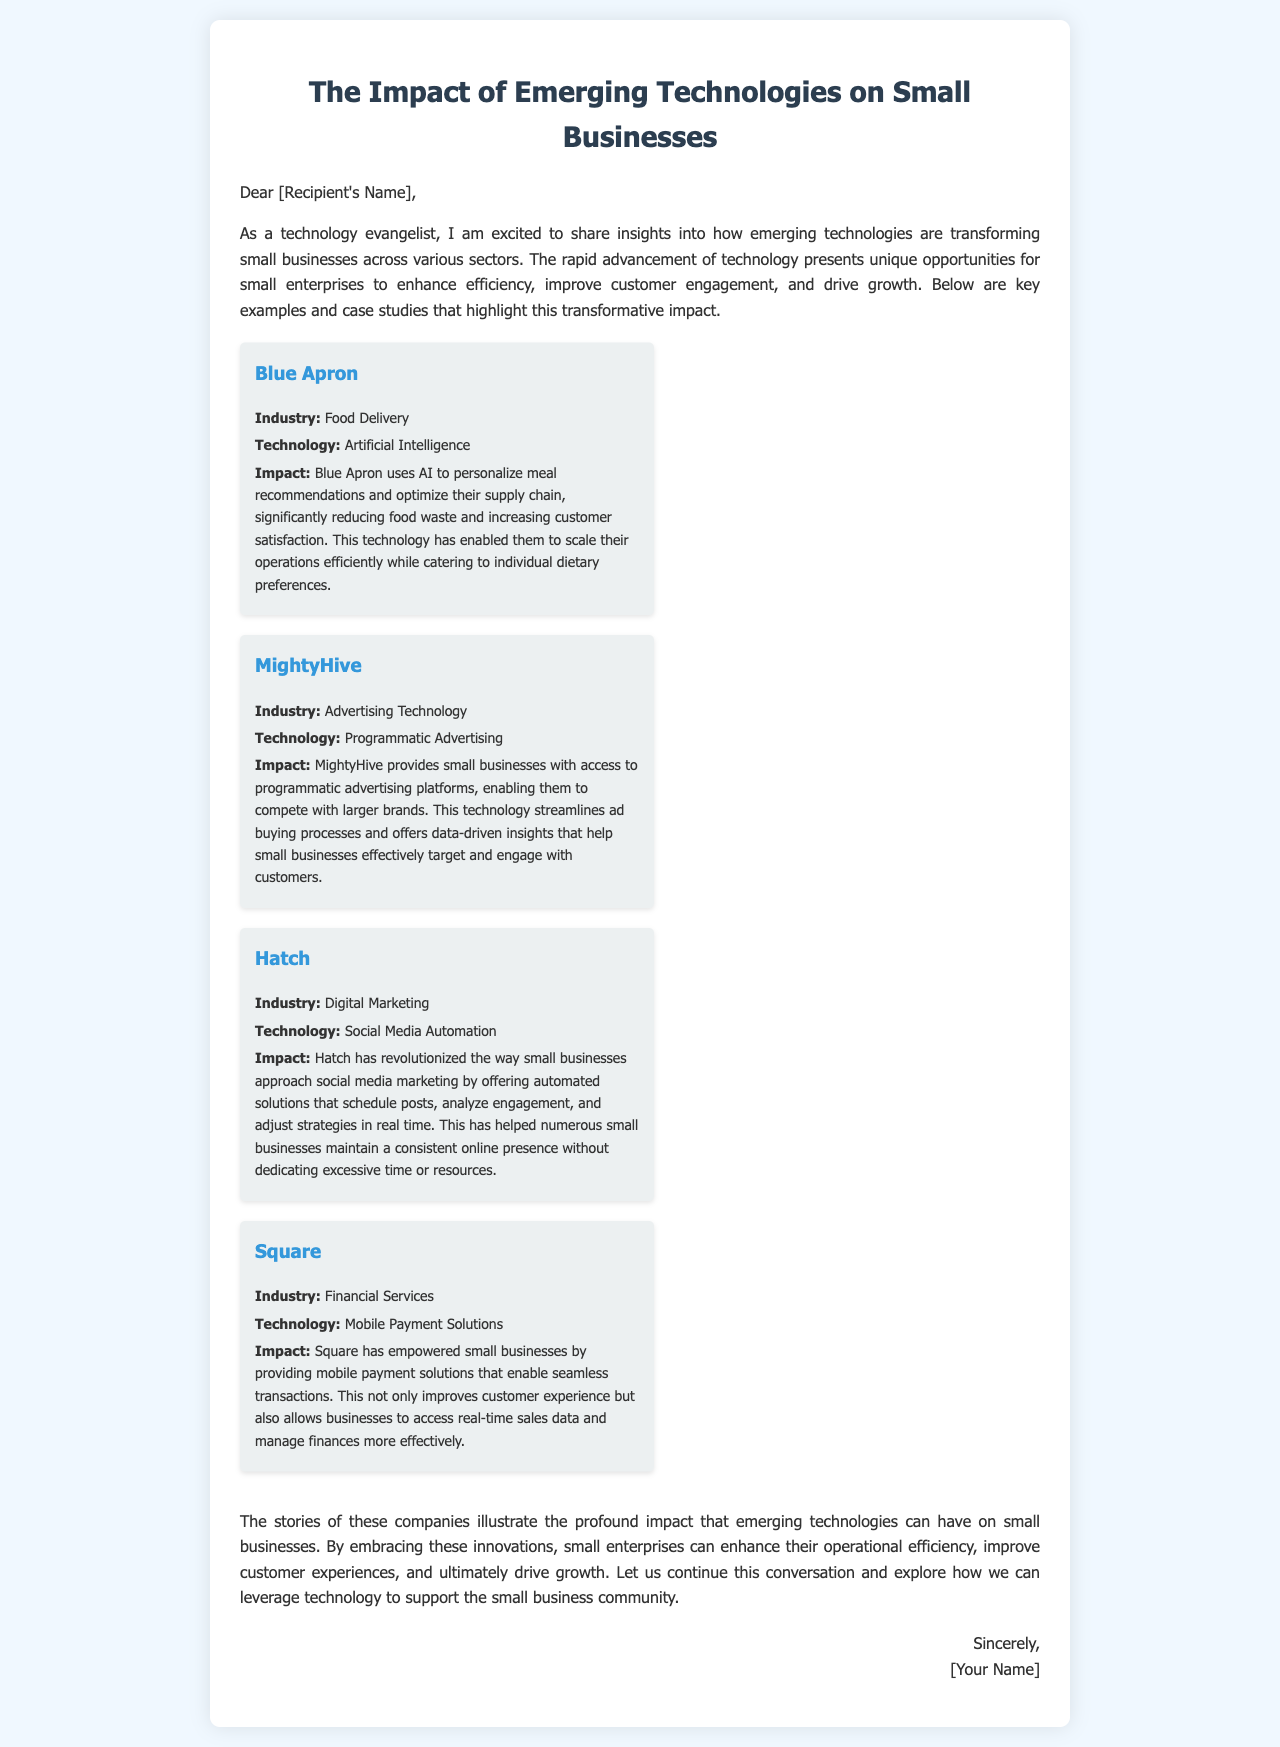What is the title of the document? The title of the document is specified at the beginning and introduces the main topic discussed.
Answer: The Impact of Emerging Technologies on Small Businesses Who is the intended recipient of the letter? The intended recipient is referenced directly in the letter's opening, indicating that it is meant for a specific person.
Answer: [Recipient's Name] Which technology does Blue Apron use? The document explicitly states the technology used by Blue Apron in their operations.
Answer: Artificial Intelligence What industry does MightyHive operate in? The document identifies the industry related to the case study of MightyHive, which is clearly stated.
Answer: Advertising Technology What is one impact of Hatch's technology? The document describes the impact Hatch's technology has on small businesses in terms of marketing strategy.
Answer: Automated solutions How does Square enhance customer experience? This question examines the mentioned benefits provided by Square in terms of customer interactions.
Answer: Mobile payment solutions What is the primary focus of the letter? The document's primary focus is elaborated in the introduction, stating the main purpose of the discussion.
Answer: Emerging technologies' impact on small businesses How many case studies are included in the document? The document outlines distinct case studies to illustrate the topic, which can be counted for clarity.
Answer: Four What does the conclusion emphasize about emerging technologies? The conclusion summarizes the significance attributed to technology in small enterprises, as stated at the end of the document.
Answer: Enhance operational efficiency Which company leverages social media automation? The document specifies which company has transformed the approach to social media marketing for small businesses.
Answer: Hatch 